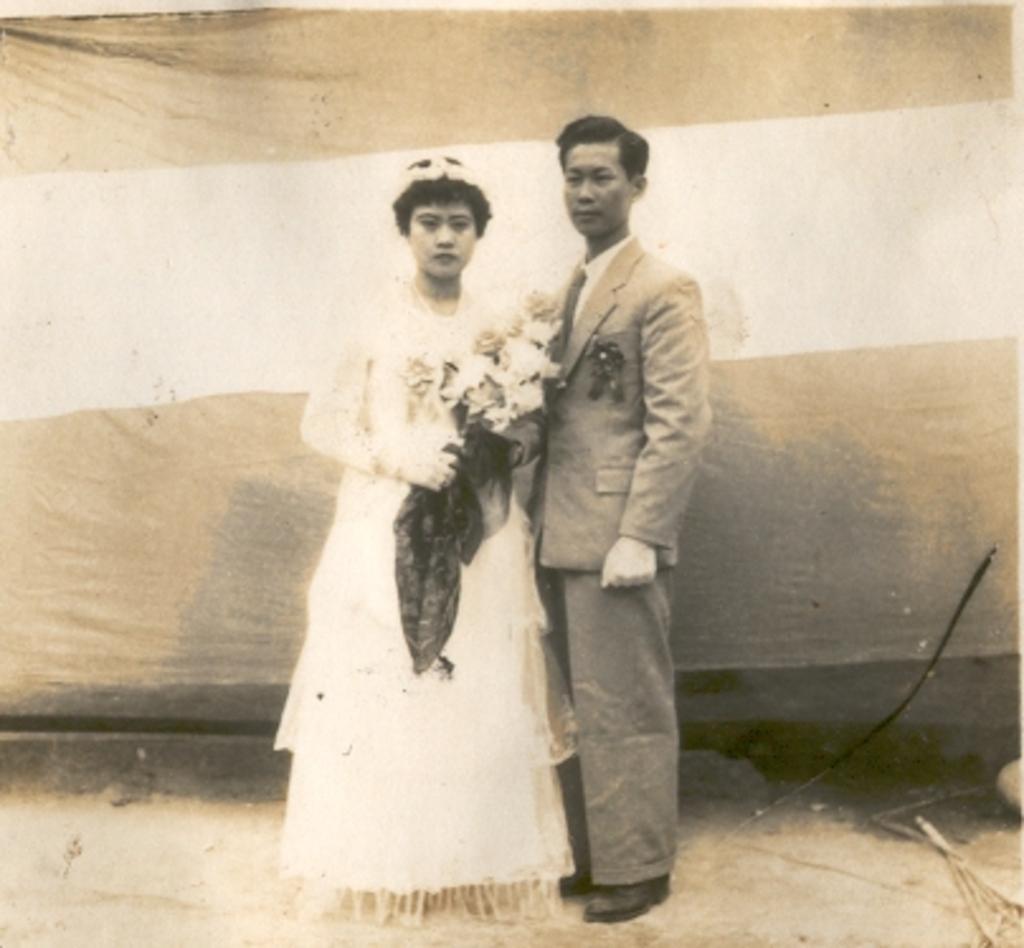Could you give a brief overview of what you see in this image? There is a man and a woman standing in the center of the image, a woman holding a bouquet, it seems like a curtain in the background area. 